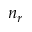<formula> <loc_0><loc_0><loc_500><loc_500>n _ { r }</formula> 